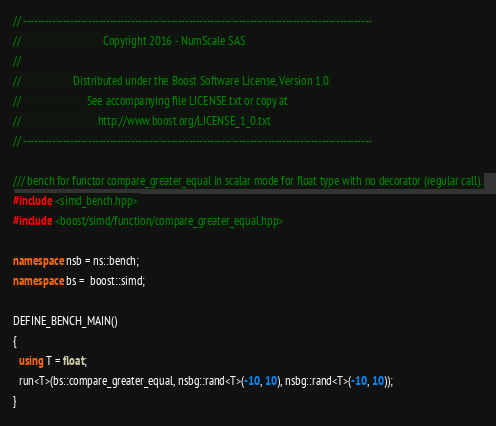Convert code to text. <code><loc_0><loc_0><loc_500><loc_500><_C++_>// -------------------------------------------------------------------------------------------------
//                              Copyright 2016 - NumScale SAS
//
//                   Distributed under the Boost Software License, Version 1.0.
//                        See accompanying file LICENSE.txt or copy at
//                            http://www.boost.org/LICENSE_1_0.txt
// -------------------------------------------------------------------------------------------------

/// bench for functor compare_greater_equal in scalar mode for float type with no decorator (regular call).
#include <simd_bench.hpp>
#include <boost/simd/function/compare_greater_equal.hpp>

namespace nsb = ns::bench;
namespace bs =  boost::simd;

DEFINE_BENCH_MAIN()
{
  using T = float;
  run<T>(bs::compare_greater_equal, nsbg::rand<T>(-10, 10), nsbg::rand<T>(-10, 10));
}
</code> 